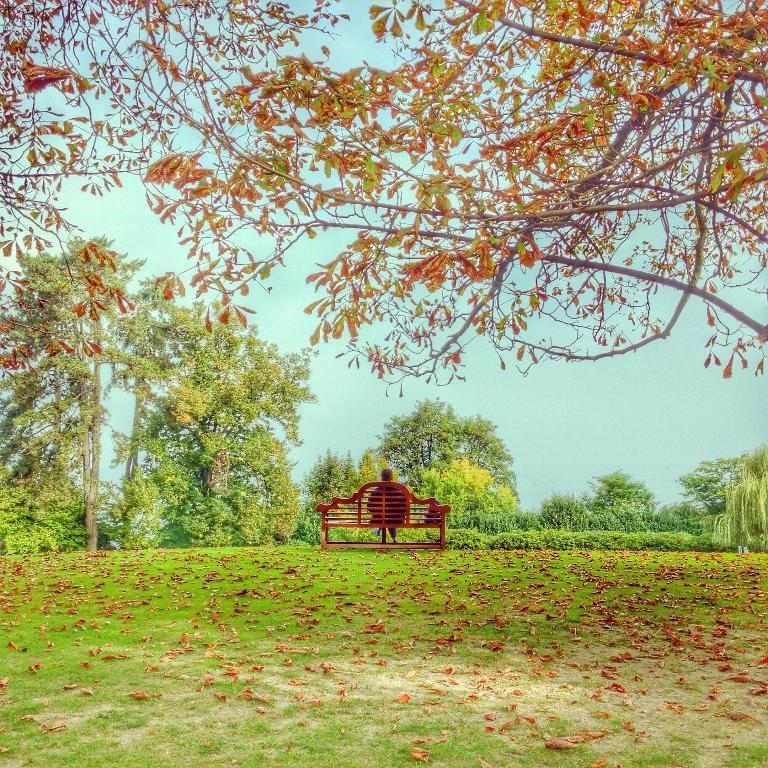What is the person in the image doing? There is a person sitting on a bench in the image. Where is the bench located? The bench is on a greenery ground. What can be observed on the ground around the bench? There are orange color leaves on the ground. What is visible in the background of the image? There are trees in the background of the image. What type of grip does the person have on the apples in the image? There are no apples present in the image, and therefore no grip can be observed. 